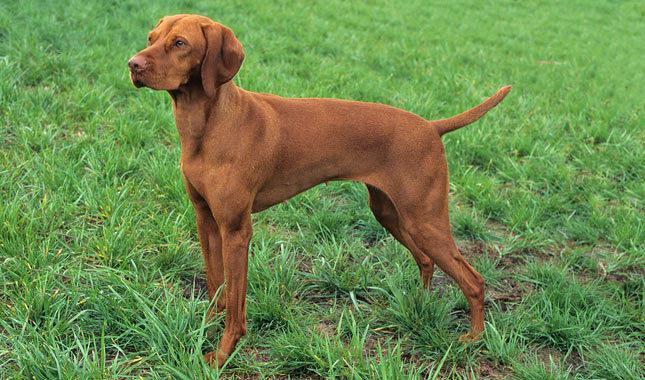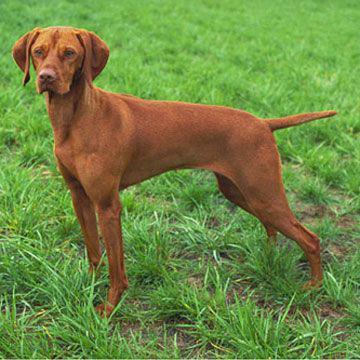The first image is the image on the left, the second image is the image on the right. For the images shown, is this caption "Both dogs are facing to the left of the images." true? Answer yes or no. Yes. The first image is the image on the left, the second image is the image on the right. Given the left and right images, does the statement "Both images contain a dog with their body facing toward the left." hold true? Answer yes or no. Yes. 